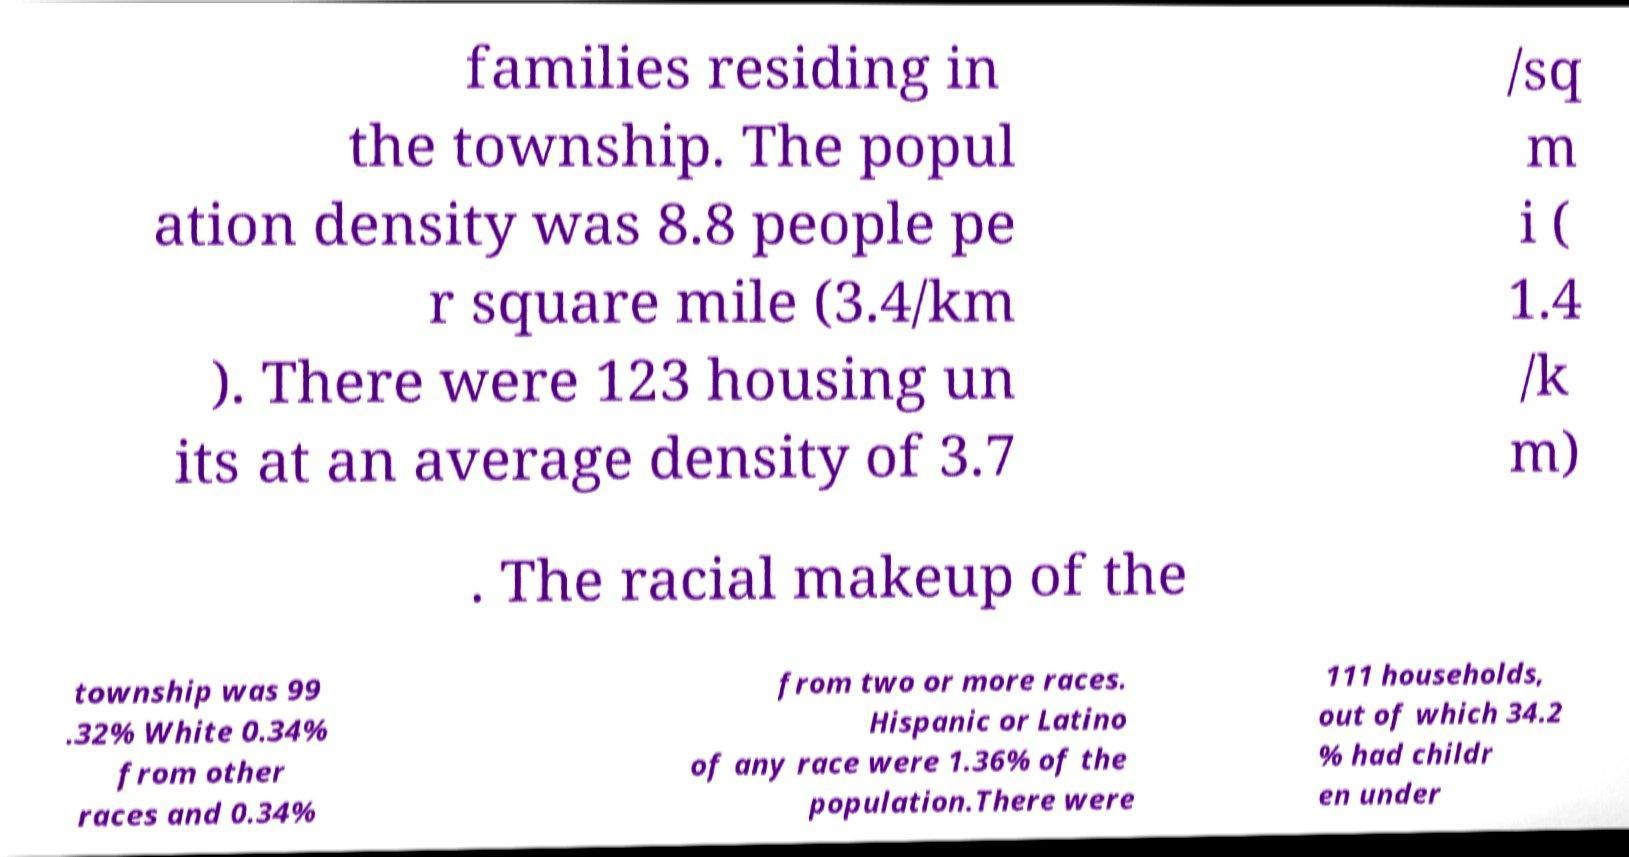Can you read and provide the text displayed in the image?This photo seems to have some interesting text. Can you extract and type it out for me? families residing in the township. The popul ation density was 8.8 people pe r square mile (3.4/km ). There were 123 housing un its at an average density of 3.7 /sq m i ( 1.4 /k m) . The racial makeup of the township was 99 .32% White 0.34% from other races and 0.34% from two or more races. Hispanic or Latino of any race were 1.36% of the population.There were 111 households, out of which 34.2 % had childr en under 